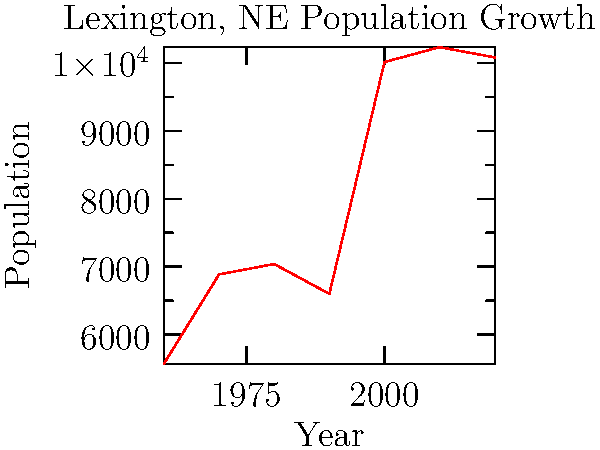Looking at the population growth of Lexington from 1960 to 2020, in which decade did our hometown experience the most significant increase in residents? To determine the decade with the most significant population increase, we need to calculate the population change for each decade and compare:

1. 1960-1970: 6887 - 5572 = 1315 increase
2. 1970-1980: 7040 - 6887 = 153 increase
3. 1980-1990: 6601 - 7040 = -439 decrease
4. 1990-2000: 10011 - 6601 = 3410 increase
5. 2000-2010: 10230 - 10011 = 219 increase
6. 2010-2020: 10079 - 10230 = -151 decrease

The largest increase occurred between 1990 and 2000, with a population growth of 3410 people.
Answer: 1990-2000 